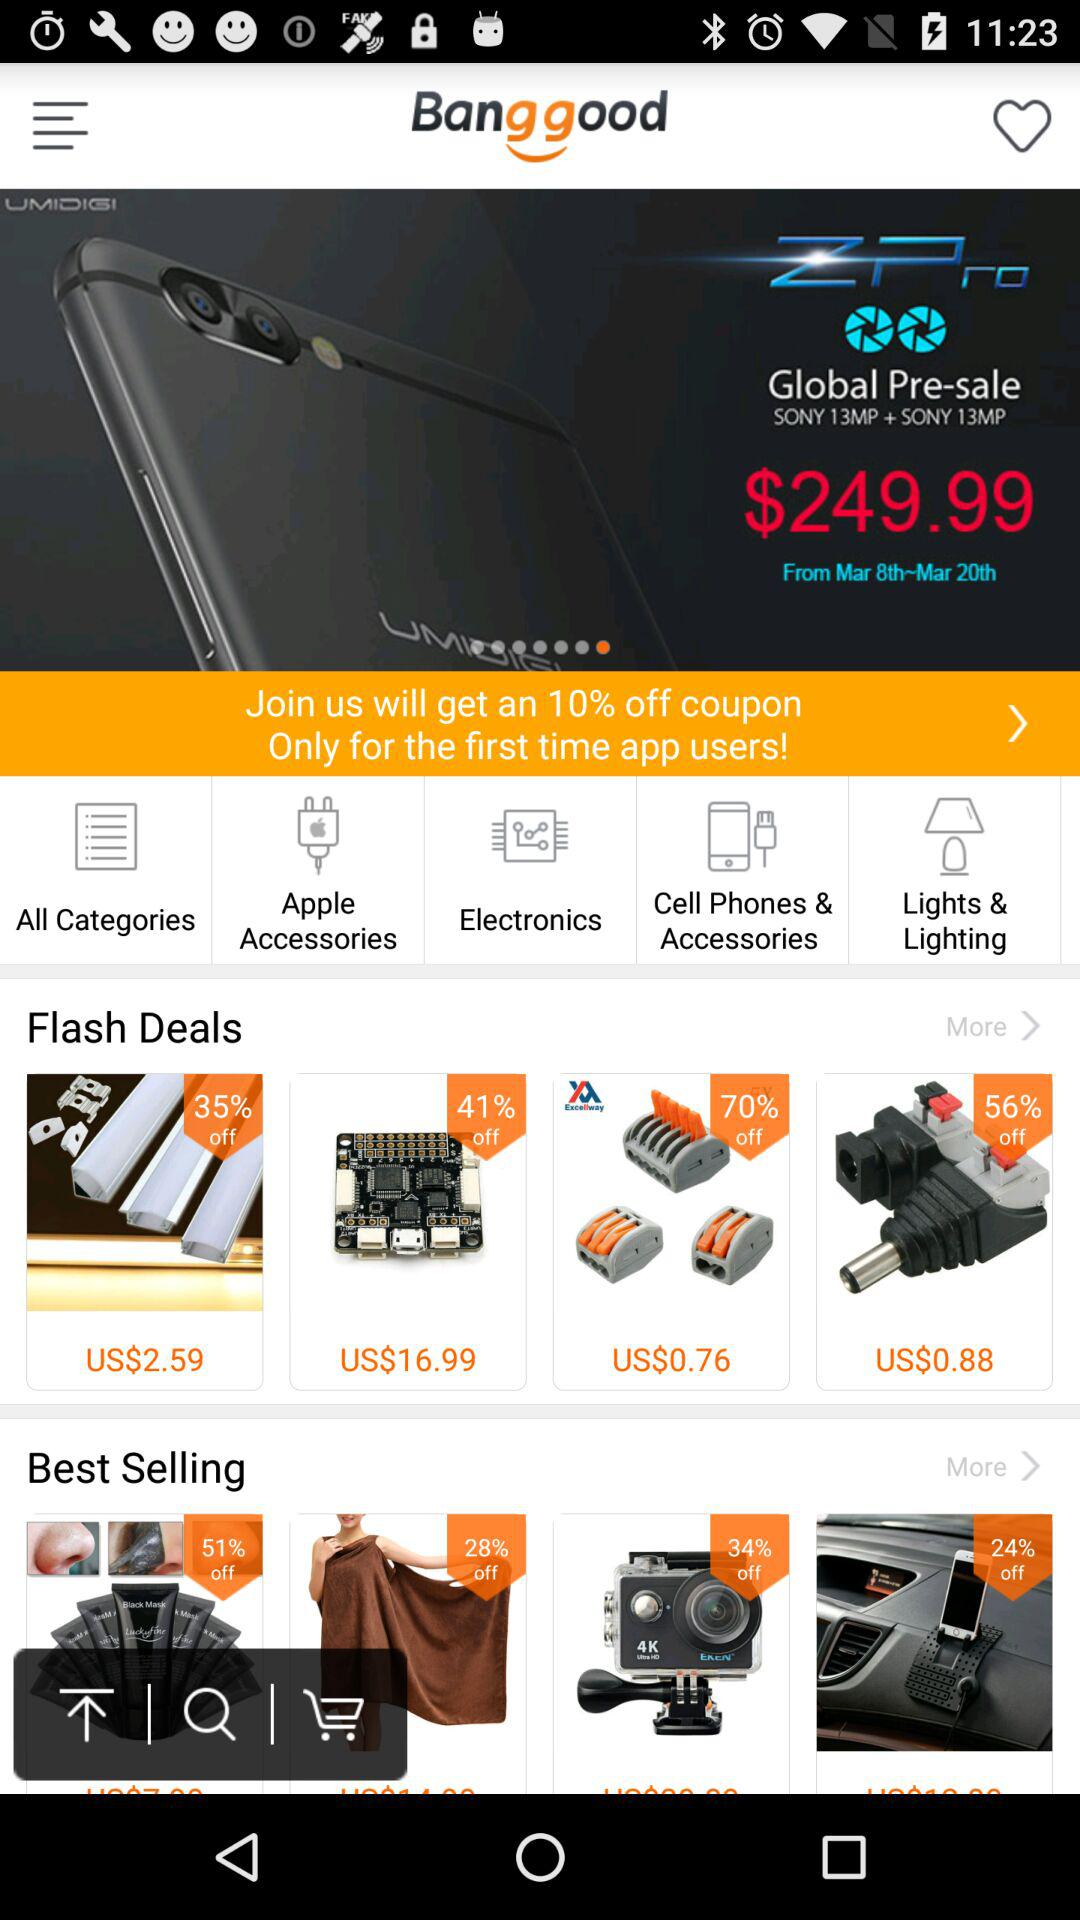What is the application name? The application name is "Bang good". 